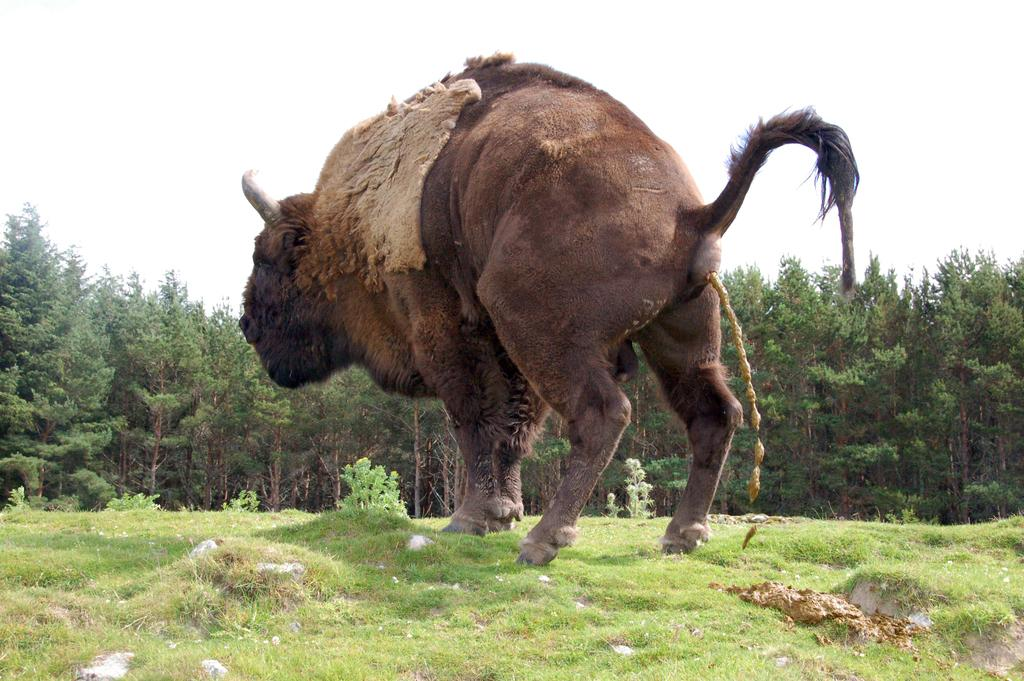What type of animal is present in the image? There is an animal in the image, but the specific type cannot be determined from the provided facts. What can be seen in the background of the image? There are trees in the background of the image. What type of cart is being used for the animal's journey in the image? There is no cart or journey present in the image; it only features an animal and trees in the background. 